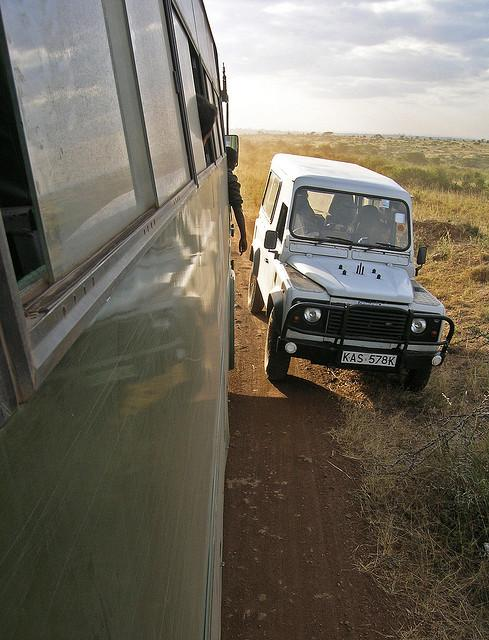In what environment are the Jeep and bus travelling? desert 